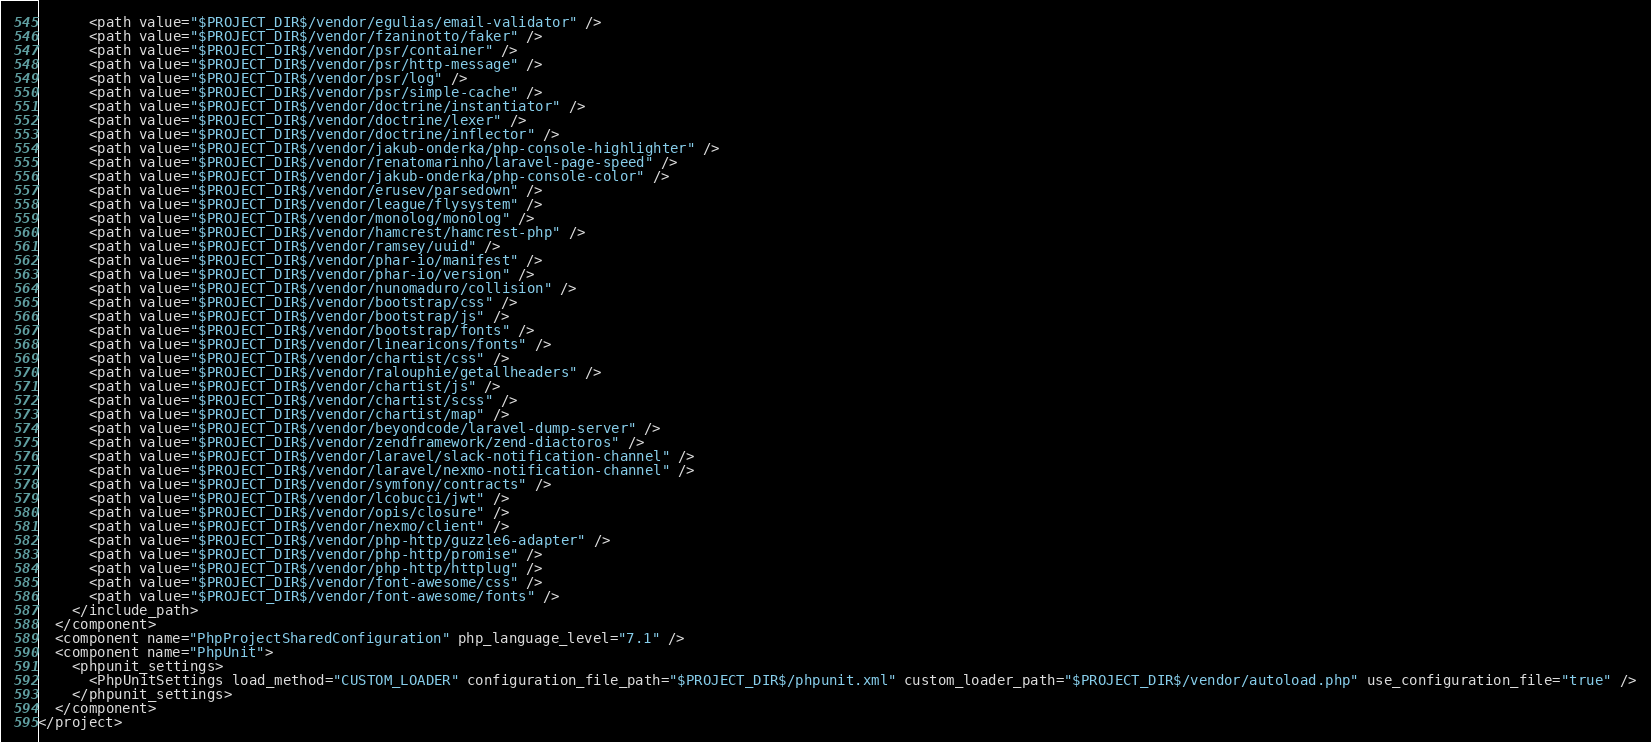<code> <loc_0><loc_0><loc_500><loc_500><_XML_>      <path value="$PROJECT_DIR$/vendor/egulias/email-validator" />
      <path value="$PROJECT_DIR$/vendor/fzaninotto/faker" />
      <path value="$PROJECT_DIR$/vendor/psr/container" />
      <path value="$PROJECT_DIR$/vendor/psr/http-message" />
      <path value="$PROJECT_DIR$/vendor/psr/log" />
      <path value="$PROJECT_DIR$/vendor/psr/simple-cache" />
      <path value="$PROJECT_DIR$/vendor/doctrine/instantiator" />
      <path value="$PROJECT_DIR$/vendor/doctrine/lexer" />
      <path value="$PROJECT_DIR$/vendor/doctrine/inflector" />
      <path value="$PROJECT_DIR$/vendor/jakub-onderka/php-console-highlighter" />
      <path value="$PROJECT_DIR$/vendor/renatomarinho/laravel-page-speed" />
      <path value="$PROJECT_DIR$/vendor/jakub-onderka/php-console-color" />
      <path value="$PROJECT_DIR$/vendor/erusev/parsedown" />
      <path value="$PROJECT_DIR$/vendor/league/flysystem" />
      <path value="$PROJECT_DIR$/vendor/monolog/monolog" />
      <path value="$PROJECT_DIR$/vendor/hamcrest/hamcrest-php" />
      <path value="$PROJECT_DIR$/vendor/ramsey/uuid" />
      <path value="$PROJECT_DIR$/vendor/phar-io/manifest" />
      <path value="$PROJECT_DIR$/vendor/phar-io/version" />
      <path value="$PROJECT_DIR$/vendor/nunomaduro/collision" />
      <path value="$PROJECT_DIR$/vendor/bootstrap/css" />
      <path value="$PROJECT_DIR$/vendor/bootstrap/js" />
      <path value="$PROJECT_DIR$/vendor/bootstrap/fonts" />
      <path value="$PROJECT_DIR$/vendor/linearicons/fonts" />
      <path value="$PROJECT_DIR$/vendor/chartist/css" />
      <path value="$PROJECT_DIR$/vendor/ralouphie/getallheaders" />
      <path value="$PROJECT_DIR$/vendor/chartist/js" />
      <path value="$PROJECT_DIR$/vendor/chartist/scss" />
      <path value="$PROJECT_DIR$/vendor/chartist/map" />
      <path value="$PROJECT_DIR$/vendor/beyondcode/laravel-dump-server" />
      <path value="$PROJECT_DIR$/vendor/zendframework/zend-diactoros" />
      <path value="$PROJECT_DIR$/vendor/laravel/slack-notification-channel" />
      <path value="$PROJECT_DIR$/vendor/laravel/nexmo-notification-channel" />
      <path value="$PROJECT_DIR$/vendor/symfony/contracts" />
      <path value="$PROJECT_DIR$/vendor/lcobucci/jwt" />
      <path value="$PROJECT_DIR$/vendor/opis/closure" />
      <path value="$PROJECT_DIR$/vendor/nexmo/client" />
      <path value="$PROJECT_DIR$/vendor/php-http/guzzle6-adapter" />
      <path value="$PROJECT_DIR$/vendor/php-http/promise" />
      <path value="$PROJECT_DIR$/vendor/php-http/httplug" />
      <path value="$PROJECT_DIR$/vendor/font-awesome/css" />
      <path value="$PROJECT_DIR$/vendor/font-awesome/fonts" />
    </include_path>
  </component>
  <component name="PhpProjectSharedConfiguration" php_language_level="7.1" />
  <component name="PhpUnit">
    <phpunit_settings>
      <PhpUnitSettings load_method="CUSTOM_LOADER" configuration_file_path="$PROJECT_DIR$/phpunit.xml" custom_loader_path="$PROJECT_DIR$/vendor/autoload.php" use_configuration_file="true" />
    </phpunit_settings>
  </component>
</project></code> 